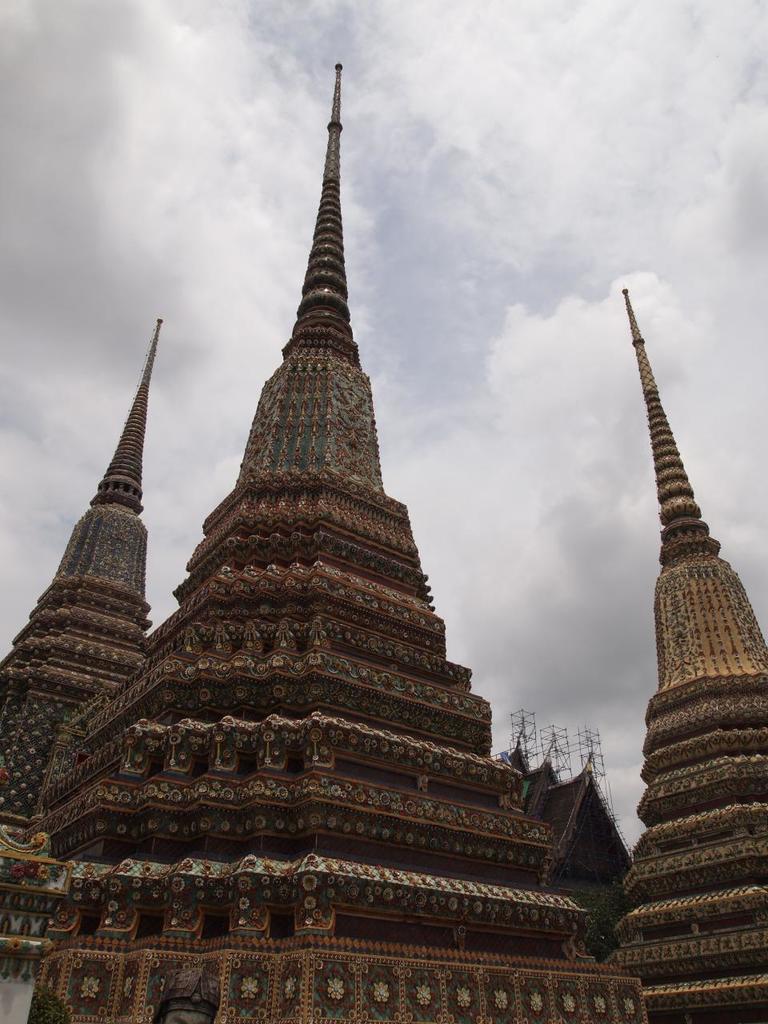Please provide a concise description of this image. In this image there are temples. 